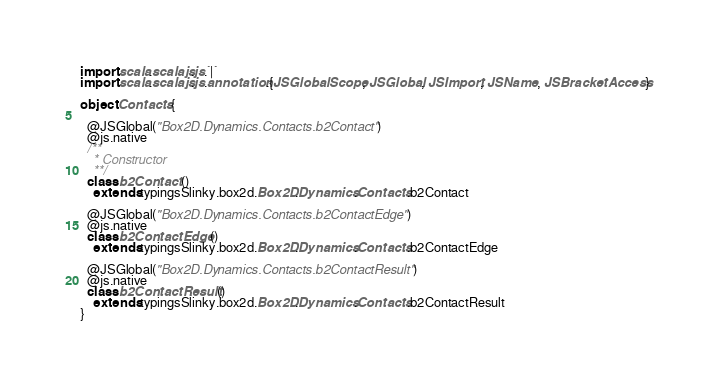Convert code to text. <code><loc_0><loc_0><loc_500><loc_500><_Scala_>import scala.scalajs.js.`|`
import scala.scalajs.js.annotation.{JSGlobalScope, JSGlobal, JSImport, JSName, JSBracketAccess}

object Contacts {
  
  @JSGlobal("Box2D.Dynamics.Contacts.b2Contact")
  @js.native
  /**
    * Constructor
    **/
  class b2Contact ()
    extends typingsSlinky.box2d.Box2D.Dynamics.Contacts.b2Contact
  
  @JSGlobal("Box2D.Dynamics.Contacts.b2ContactEdge")
  @js.native
  class b2ContactEdge ()
    extends typingsSlinky.box2d.Box2D.Dynamics.Contacts.b2ContactEdge
  
  @JSGlobal("Box2D.Dynamics.Contacts.b2ContactResult")
  @js.native
  class b2ContactResult ()
    extends typingsSlinky.box2d.Box2D.Dynamics.Contacts.b2ContactResult
}
</code> 